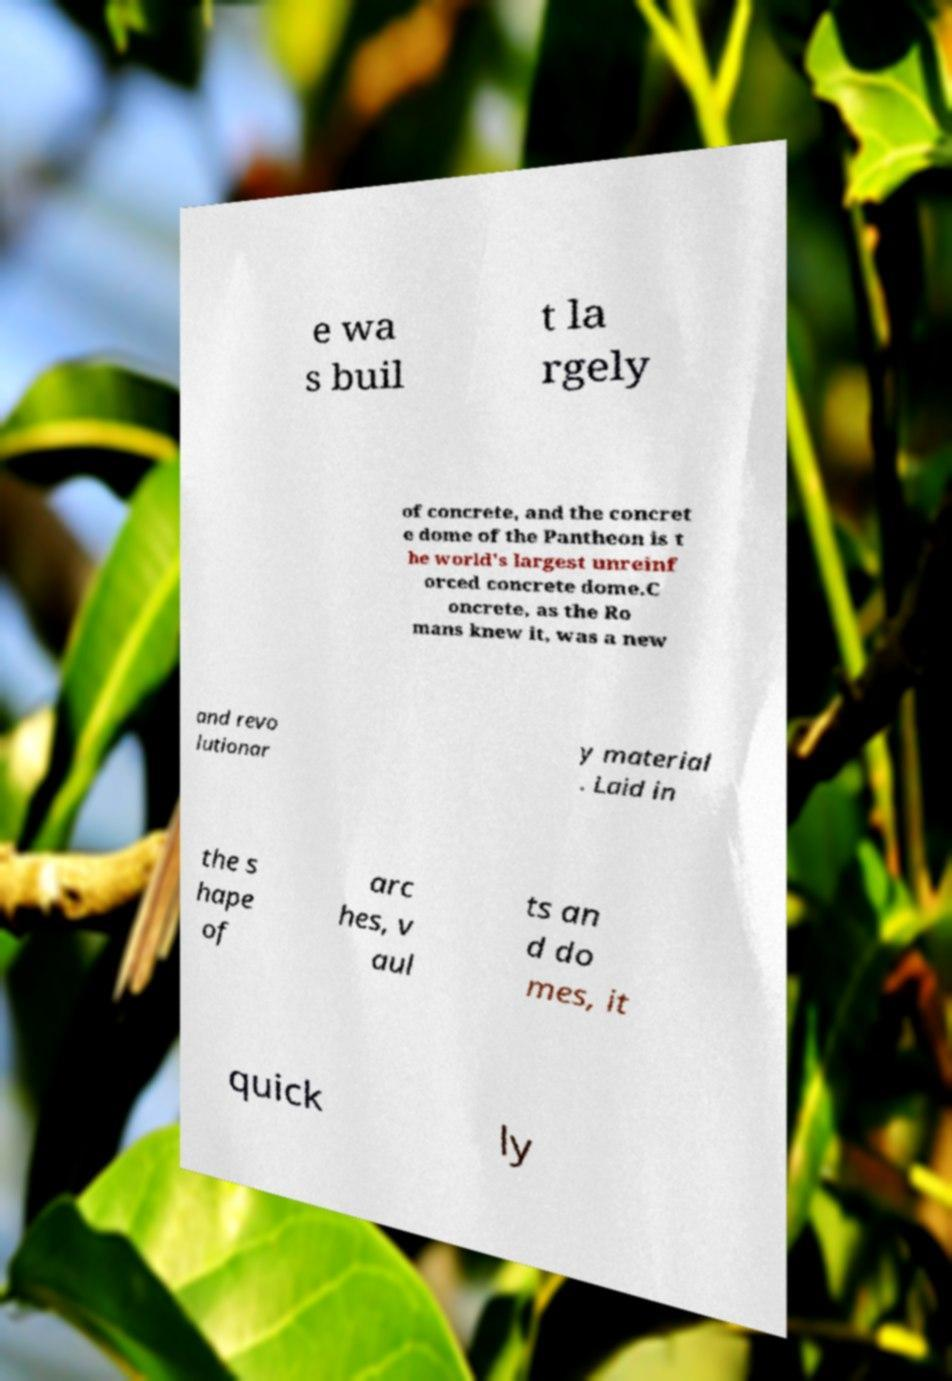I need the written content from this picture converted into text. Can you do that? e wa s buil t la rgely of concrete, and the concret e dome of the Pantheon is t he world's largest unreinf orced concrete dome.C oncrete, as the Ro mans knew it, was a new and revo lutionar y material . Laid in the s hape of arc hes, v aul ts an d do mes, it quick ly 